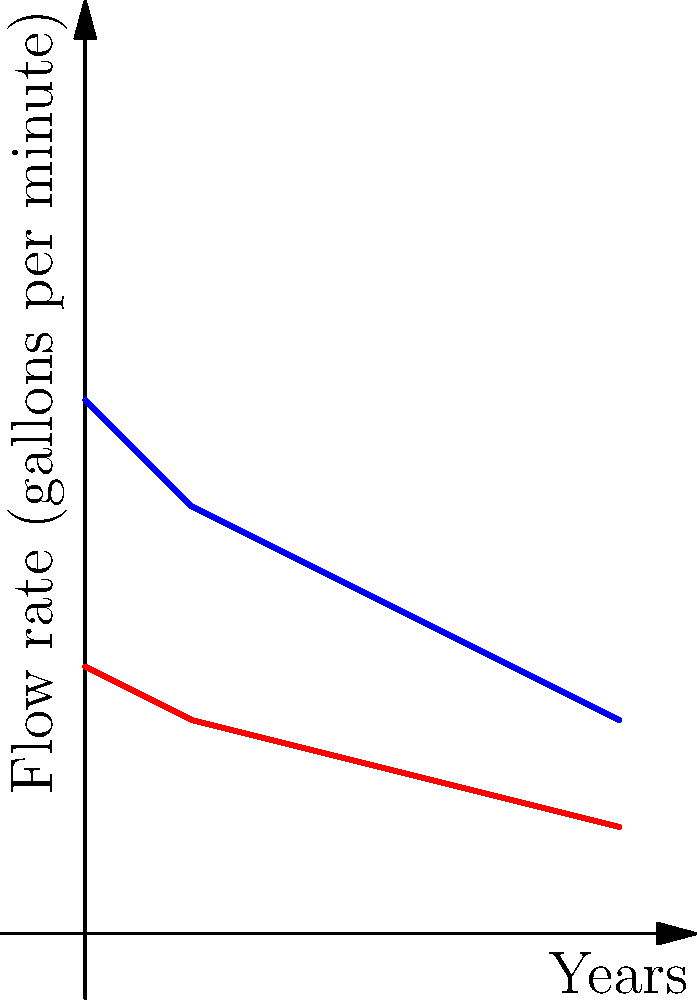Based on the flow rate chart comparing standard and low-flow plumbing fixtures over a 5-year period, estimate the potential water savings (in gallons per minute) that could be achieved by implementing low-flow fixtures in all new building constructions across the state after 5 years. To estimate the potential water savings, we need to follow these steps:

1. Identify the flow rates at the 5-year mark:
   - Standard fixtures: 2 gallons per minute
   - Low-flow fixtures: 1 gallon per minute

2. Calculate the difference in flow rates:
   $2 \text{ gal/min} - 1 \text{ gal/min} = 1 \text{ gal/min}$

3. This difference represents the potential water savings per fixture.

4. Consider the scale of implementation:
   - As a state senator, we're looking at state-wide implementation in new constructions.
   - The actual number of fixtures would be large, but we're asked for the savings per minute.

5. The potential water savings remain 1 gallon per minute per fixture.

6. For a more comprehensive analysis, we would need data on:
   - Number of new buildings constructed annually
   - Average number of fixtures per building
   - Actual usage patterns

However, based solely on the information provided in the chart, the estimated potential water savings per fixture is 1 gallon per minute after 5 years.
Answer: 1 gallon per minute per fixture 